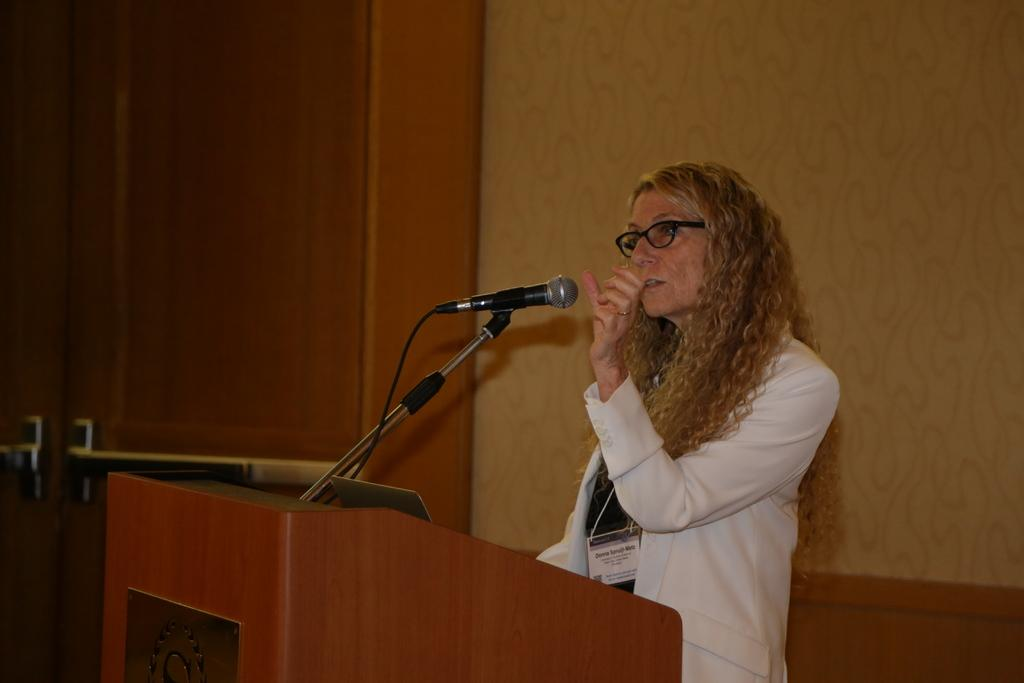Who is the main subject in the image? There is a woman in the image. What is the woman doing in the image? The woman is standing in the image. What is the woman wearing in the image? The woman is wearing a white coat in the image. What is in front of the woman in the image? There is a podium in front of the woman in the image. What is on the podium in the image? There is a microphone (mic) on the podium in the image. What can be seen in the background of the image? There is a wall and a cupboard in the background of the image. Can you see any planes flying over the mountain in the image? There is no mountain or planes present in the image. 